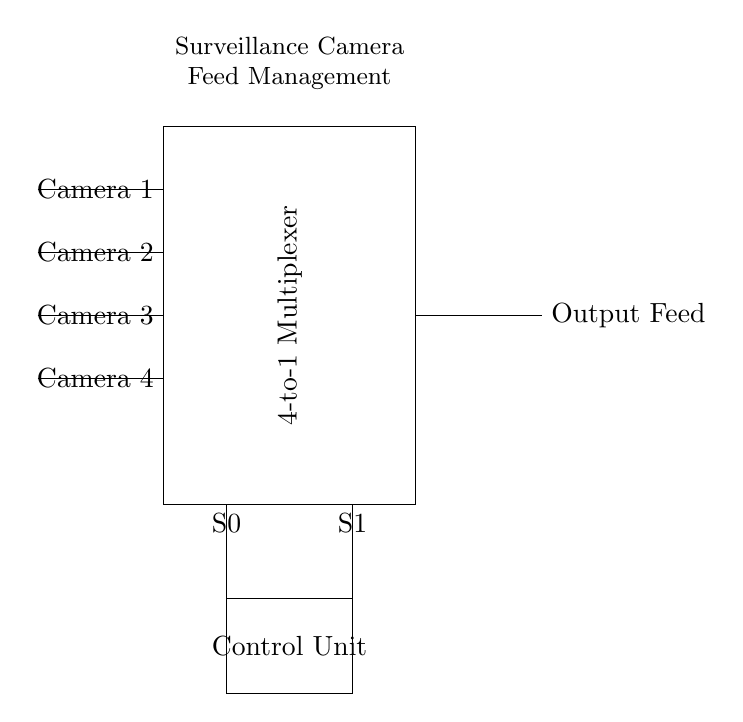What type of multiplexer is shown in the circuit? The circuit diagram indicates a 4-to-1 multiplexer, as represented by the notation within the rectangle. This means it selects one of four inputs based on two select lines.
Answer: 4-to-1 How many cameras are connected to the multiplexer? The circuit has four input lines, each representing a camera, connected to the multiplexer. This indicates that four cameras can provide video feeds.
Answer: Four What do the select lines control? The select lines control which camera feed is sent to the output. The two select lines S0 and S1 determine which of the four cameras is selected based on their binary state.
Answer: Camera selection What is the role of the control unit in this circuit? The control unit processes the inputs from the select lines and assists in directing which camera feed is passed through to the output. It manages the selection logic of the multiplexer.
Answer: Selection logic If S0 is 1 and S1 is 0, which camera feed will be output? In binary selection, S1 S0 corresponds to the camera feed being selected based on the combination given. Here, 10 selects Camera 2, following the binary count from 00 to 11 for Camera 1 to Camera 4.
Answer: Camera 2 What is the output line labeled? The output is labeled as "Output Feed," indicating that this is where the selected camera feed is transmitted after passing through the multiplexer.
Answer: Output Feed 